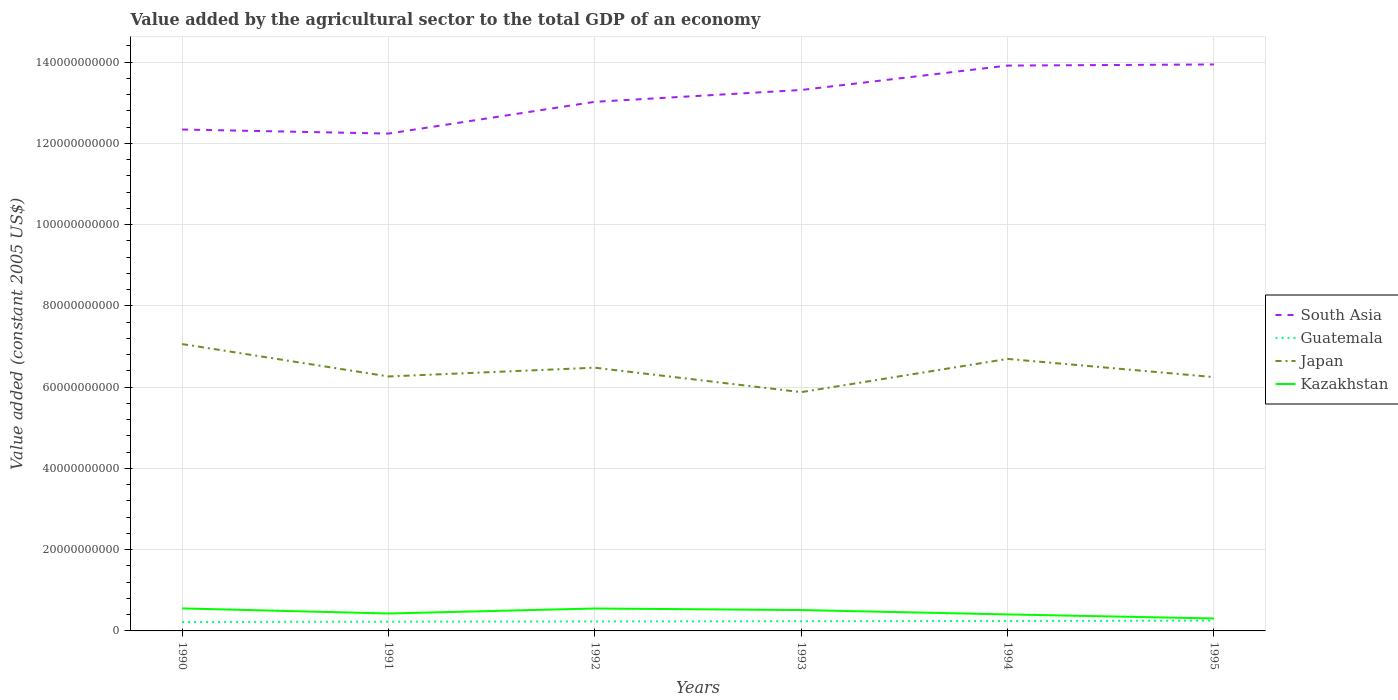Does the line corresponding to South Asia intersect with the line corresponding to Guatemala?
Provide a short and direct response. No. Across all years, what is the maximum value added by the agricultural sector in Japan?
Your answer should be very brief. 5.88e+1. In which year was the value added by the agricultural sector in South Asia maximum?
Provide a succinct answer. 1991. What is the total value added by the agricultural sector in South Asia in the graph?
Keep it short and to the point. -6.01e+09. What is the difference between the highest and the second highest value added by the agricultural sector in Guatemala?
Offer a terse response. 3.31e+08. What is the difference between the highest and the lowest value added by the agricultural sector in Kazakhstan?
Provide a short and direct response. 3. How many years are there in the graph?
Keep it short and to the point. 6. What is the difference between two consecutive major ticks on the Y-axis?
Your answer should be very brief. 2.00e+1. Does the graph contain any zero values?
Ensure brevity in your answer.  No. Where does the legend appear in the graph?
Make the answer very short. Center right. How many legend labels are there?
Keep it short and to the point. 4. What is the title of the graph?
Offer a terse response. Value added by the agricultural sector to the total GDP of an economy. What is the label or title of the Y-axis?
Ensure brevity in your answer.  Value added (constant 2005 US$). What is the Value added (constant 2005 US$) in South Asia in 1990?
Offer a very short reply. 1.23e+11. What is the Value added (constant 2005 US$) in Guatemala in 1990?
Give a very brief answer. 2.20e+09. What is the Value added (constant 2005 US$) in Japan in 1990?
Keep it short and to the point. 7.06e+1. What is the Value added (constant 2005 US$) in Kazakhstan in 1990?
Your response must be concise. 5.54e+09. What is the Value added (constant 2005 US$) in South Asia in 1991?
Your answer should be very brief. 1.22e+11. What is the Value added (constant 2005 US$) of Guatemala in 1991?
Provide a short and direct response. 2.27e+09. What is the Value added (constant 2005 US$) of Japan in 1991?
Your response must be concise. 6.26e+1. What is the Value added (constant 2005 US$) in Kazakhstan in 1991?
Give a very brief answer. 4.29e+09. What is the Value added (constant 2005 US$) of South Asia in 1992?
Give a very brief answer. 1.30e+11. What is the Value added (constant 2005 US$) in Guatemala in 1992?
Make the answer very short. 2.33e+09. What is the Value added (constant 2005 US$) in Japan in 1992?
Provide a succinct answer. 6.48e+1. What is the Value added (constant 2005 US$) in Kazakhstan in 1992?
Offer a terse response. 5.52e+09. What is the Value added (constant 2005 US$) in South Asia in 1993?
Ensure brevity in your answer.  1.33e+11. What is the Value added (constant 2005 US$) in Guatemala in 1993?
Keep it short and to the point. 2.39e+09. What is the Value added (constant 2005 US$) in Japan in 1993?
Your answer should be compact. 5.88e+1. What is the Value added (constant 2005 US$) of Kazakhstan in 1993?
Keep it short and to the point. 5.14e+09. What is the Value added (constant 2005 US$) in South Asia in 1994?
Ensure brevity in your answer.  1.39e+11. What is the Value added (constant 2005 US$) of Guatemala in 1994?
Give a very brief answer. 2.44e+09. What is the Value added (constant 2005 US$) in Japan in 1994?
Keep it short and to the point. 6.69e+1. What is the Value added (constant 2005 US$) of Kazakhstan in 1994?
Offer a terse response. 4.06e+09. What is the Value added (constant 2005 US$) in South Asia in 1995?
Your answer should be compact. 1.39e+11. What is the Value added (constant 2005 US$) of Guatemala in 1995?
Keep it short and to the point. 2.53e+09. What is the Value added (constant 2005 US$) in Japan in 1995?
Provide a short and direct response. 6.25e+1. What is the Value added (constant 2005 US$) in Kazakhstan in 1995?
Your answer should be very brief. 3.07e+09. Across all years, what is the maximum Value added (constant 2005 US$) in South Asia?
Your answer should be compact. 1.39e+11. Across all years, what is the maximum Value added (constant 2005 US$) of Guatemala?
Offer a terse response. 2.53e+09. Across all years, what is the maximum Value added (constant 2005 US$) in Japan?
Provide a succinct answer. 7.06e+1. Across all years, what is the maximum Value added (constant 2005 US$) of Kazakhstan?
Make the answer very short. 5.54e+09. Across all years, what is the minimum Value added (constant 2005 US$) in South Asia?
Your answer should be very brief. 1.22e+11. Across all years, what is the minimum Value added (constant 2005 US$) in Guatemala?
Provide a succinct answer. 2.20e+09. Across all years, what is the minimum Value added (constant 2005 US$) in Japan?
Your response must be concise. 5.88e+1. Across all years, what is the minimum Value added (constant 2005 US$) of Kazakhstan?
Offer a terse response. 3.07e+09. What is the total Value added (constant 2005 US$) in South Asia in the graph?
Your response must be concise. 7.88e+11. What is the total Value added (constant 2005 US$) in Guatemala in the graph?
Your answer should be compact. 1.42e+1. What is the total Value added (constant 2005 US$) of Japan in the graph?
Offer a terse response. 3.86e+11. What is the total Value added (constant 2005 US$) in Kazakhstan in the graph?
Provide a short and direct response. 2.76e+1. What is the difference between the Value added (constant 2005 US$) in South Asia in 1990 and that in 1991?
Your response must be concise. 9.99e+08. What is the difference between the Value added (constant 2005 US$) in Guatemala in 1990 and that in 1991?
Ensure brevity in your answer.  -6.82e+07. What is the difference between the Value added (constant 2005 US$) of Japan in 1990 and that in 1991?
Your answer should be very brief. 7.98e+09. What is the difference between the Value added (constant 2005 US$) in Kazakhstan in 1990 and that in 1991?
Ensure brevity in your answer.  1.25e+09. What is the difference between the Value added (constant 2005 US$) of South Asia in 1990 and that in 1992?
Your answer should be compact. -6.81e+09. What is the difference between the Value added (constant 2005 US$) of Guatemala in 1990 and that in 1992?
Offer a terse response. -1.36e+08. What is the difference between the Value added (constant 2005 US$) in Japan in 1990 and that in 1992?
Provide a succinct answer. 5.82e+09. What is the difference between the Value added (constant 2005 US$) in Kazakhstan in 1990 and that in 1992?
Offer a very short reply. 2.14e+07. What is the difference between the Value added (constant 2005 US$) in South Asia in 1990 and that in 1993?
Keep it short and to the point. -9.73e+09. What is the difference between the Value added (constant 2005 US$) in Guatemala in 1990 and that in 1993?
Provide a short and direct response. -1.87e+08. What is the difference between the Value added (constant 2005 US$) in Japan in 1990 and that in 1993?
Keep it short and to the point. 1.18e+1. What is the difference between the Value added (constant 2005 US$) of Kazakhstan in 1990 and that in 1993?
Offer a terse response. 4.02e+08. What is the difference between the Value added (constant 2005 US$) in South Asia in 1990 and that in 1994?
Your response must be concise. -1.57e+1. What is the difference between the Value added (constant 2005 US$) of Guatemala in 1990 and that in 1994?
Offer a very short reply. -2.46e+08. What is the difference between the Value added (constant 2005 US$) in Japan in 1990 and that in 1994?
Keep it short and to the point. 3.66e+09. What is the difference between the Value added (constant 2005 US$) in Kazakhstan in 1990 and that in 1994?
Provide a succinct answer. 1.48e+09. What is the difference between the Value added (constant 2005 US$) in South Asia in 1990 and that in 1995?
Your answer should be very brief. -1.60e+1. What is the difference between the Value added (constant 2005 US$) in Guatemala in 1990 and that in 1995?
Keep it short and to the point. -3.31e+08. What is the difference between the Value added (constant 2005 US$) in Japan in 1990 and that in 1995?
Your response must be concise. 8.13e+09. What is the difference between the Value added (constant 2005 US$) in Kazakhstan in 1990 and that in 1995?
Offer a terse response. 2.47e+09. What is the difference between the Value added (constant 2005 US$) of South Asia in 1991 and that in 1992?
Offer a very short reply. -7.81e+09. What is the difference between the Value added (constant 2005 US$) in Guatemala in 1991 and that in 1992?
Your answer should be compact. -6.77e+07. What is the difference between the Value added (constant 2005 US$) of Japan in 1991 and that in 1992?
Your answer should be very brief. -2.16e+09. What is the difference between the Value added (constant 2005 US$) in Kazakhstan in 1991 and that in 1992?
Your answer should be very brief. -1.23e+09. What is the difference between the Value added (constant 2005 US$) of South Asia in 1991 and that in 1993?
Your answer should be very brief. -1.07e+1. What is the difference between the Value added (constant 2005 US$) of Guatemala in 1991 and that in 1993?
Ensure brevity in your answer.  -1.19e+08. What is the difference between the Value added (constant 2005 US$) in Japan in 1991 and that in 1993?
Your answer should be very brief. 3.86e+09. What is the difference between the Value added (constant 2005 US$) of Kazakhstan in 1991 and that in 1993?
Your answer should be very brief. -8.50e+08. What is the difference between the Value added (constant 2005 US$) of South Asia in 1991 and that in 1994?
Provide a succinct answer. -1.67e+1. What is the difference between the Value added (constant 2005 US$) in Guatemala in 1991 and that in 1994?
Your answer should be compact. -1.78e+08. What is the difference between the Value added (constant 2005 US$) in Japan in 1991 and that in 1994?
Your answer should be very brief. -4.32e+09. What is the difference between the Value added (constant 2005 US$) of Kazakhstan in 1991 and that in 1994?
Ensure brevity in your answer.  2.29e+08. What is the difference between the Value added (constant 2005 US$) in South Asia in 1991 and that in 1995?
Your answer should be very brief. -1.70e+1. What is the difference between the Value added (constant 2005 US$) of Guatemala in 1991 and that in 1995?
Your response must be concise. -2.63e+08. What is the difference between the Value added (constant 2005 US$) of Japan in 1991 and that in 1995?
Your response must be concise. 1.56e+08. What is the difference between the Value added (constant 2005 US$) in Kazakhstan in 1991 and that in 1995?
Give a very brief answer. 1.22e+09. What is the difference between the Value added (constant 2005 US$) in South Asia in 1992 and that in 1993?
Offer a terse response. -2.91e+09. What is the difference between the Value added (constant 2005 US$) of Guatemala in 1992 and that in 1993?
Offer a terse response. -5.15e+07. What is the difference between the Value added (constant 2005 US$) of Japan in 1992 and that in 1993?
Your answer should be very brief. 6.01e+09. What is the difference between the Value added (constant 2005 US$) in Kazakhstan in 1992 and that in 1993?
Give a very brief answer. 3.81e+08. What is the difference between the Value added (constant 2005 US$) in South Asia in 1992 and that in 1994?
Provide a succinct answer. -8.92e+09. What is the difference between the Value added (constant 2005 US$) of Guatemala in 1992 and that in 1994?
Provide a short and direct response. -1.10e+08. What is the difference between the Value added (constant 2005 US$) of Japan in 1992 and that in 1994?
Your answer should be very brief. -2.16e+09. What is the difference between the Value added (constant 2005 US$) of Kazakhstan in 1992 and that in 1994?
Keep it short and to the point. 1.46e+09. What is the difference between the Value added (constant 2005 US$) of South Asia in 1992 and that in 1995?
Your response must be concise. -9.20e+09. What is the difference between the Value added (constant 2005 US$) in Guatemala in 1992 and that in 1995?
Your answer should be very brief. -1.96e+08. What is the difference between the Value added (constant 2005 US$) of Japan in 1992 and that in 1995?
Give a very brief answer. 2.31e+09. What is the difference between the Value added (constant 2005 US$) in Kazakhstan in 1992 and that in 1995?
Your response must be concise. 2.45e+09. What is the difference between the Value added (constant 2005 US$) in South Asia in 1993 and that in 1994?
Offer a very short reply. -6.01e+09. What is the difference between the Value added (constant 2005 US$) of Guatemala in 1993 and that in 1994?
Make the answer very short. -5.84e+07. What is the difference between the Value added (constant 2005 US$) in Japan in 1993 and that in 1994?
Offer a very short reply. -8.18e+09. What is the difference between the Value added (constant 2005 US$) of Kazakhstan in 1993 and that in 1994?
Offer a terse response. 1.08e+09. What is the difference between the Value added (constant 2005 US$) of South Asia in 1993 and that in 1995?
Keep it short and to the point. -6.28e+09. What is the difference between the Value added (constant 2005 US$) of Guatemala in 1993 and that in 1995?
Ensure brevity in your answer.  -1.44e+08. What is the difference between the Value added (constant 2005 US$) of Japan in 1993 and that in 1995?
Offer a very short reply. -3.70e+09. What is the difference between the Value added (constant 2005 US$) in Kazakhstan in 1993 and that in 1995?
Make the answer very short. 2.07e+09. What is the difference between the Value added (constant 2005 US$) in South Asia in 1994 and that in 1995?
Your response must be concise. -2.77e+08. What is the difference between the Value added (constant 2005 US$) in Guatemala in 1994 and that in 1995?
Make the answer very short. -8.57e+07. What is the difference between the Value added (constant 2005 US$) in Japan in 1994 and that in 1995?
Provide a short and direct response. 4.48e+09. What is the difference between the Value added (constant 2005 US$) of Kazakhstan in 1994 and that in 1995?
Keep it short and to the point. 9.90e+08. What is the difference between the Value added (constant 2005 US$) in South Asia in 1990 and the Value added (constant 2005 US$) in Guatemala in 1991?
Provide a short and direct response. 1.21e+11. What is the difference between the Value added (constant 2005 US$) of South Asia in 1990 and the Value added (constant 2005 US$) of Japan in 1991?
Offer a very short reply. 6.08e+1. What is the difference between the Value added (constant 2005 US$) of South Asia in 1990 and the Value added (constant 2005 US$) of Kazakhstan in 1991?
Your answer should be very brief. 1.19e+11. What is the difference between the Value added (constant 2005 US$) in Guatemala in 1990 and the Value added (constant 2005 US$) in Japan in 1991?
Provide a short and direct response. -6.04e+1. What is the difference between the Value added (constant 2005 US$) of Guatemala in 1990 and the Value added (constant 2005 US$) of Kazakhstan in 1991?
Offer a terse response. -2.09e+09. What is the difference between the Value added (constant 2005 US$) of Japan in 1990 and the Value added (constant 2005 US$) of Kazakhstan in 1991?
Your answer should be very brief. 6.63e+1. What is the difference between the Value added (constant 2005 US$) in South Asia in 1990 and the Value added (constant 2005 US$) in Guatemala in 1992?
Offer a terse response. 1.21e+11. What is the difference between the Value added (constant 2005 US$) in South Asia in 1990 and the Value added (constant 2005 US$) in Japan in 1992?
Your answer should be compact. 5.86e+1. What is the difference between the Value added (constant 2005 US$) in South Asia in 1990 and the Value added (constant 2005 US$) in Kazakhstan in 1992?
Keep it short and to the point. 1.18e+11. What is the difference between the Value added (constant 2005 US$) of Guatemala in 1990 and the Value added (constant 2005 US$) of Japan in 1992?
Offer a very short reply. -6.26e+1. What is the difference between the Value added (constant 2005 US$) of Guatemala in 1990 and the Value added (constant 2005 US$) of Kazakhstan in 1992?
Offer a very short reply. -3.32e+09. What is the difference between the Value added (constant 2005 US$) in Japan in 1990 and the Value added (constant 2005 US$) in Kazakhstan in 1992?
Your response must be concise. 6.51e+1. What is the difference between the Value added (constant 2005 US$) of South Asia in 1990 and the Value added (constant 2005 US$) of Guatemala in 1993?
Your answer should be very brief. 1.21e+11. What is the difference between the Value added (constant 2005 US$) of South Asia in 1990 and the Value added (constant 2005 US$) of Japan in 1993?
Give a very brief answer. 6.46e+1. What is the difference between the Value added (constant 2005 US$) in South Asia in 1990 and the Value added (constant 2005 US$) in Kazakhstan in 1993?
Your answer should be very brief. 1.18e+11. What is the difference between the Value added (constant 2005 US$) of Guatemala in 1990 and the Value added (constant 2005 US$) of Japan in 1993?
Ensure brevity in your answer.  -5.66e+1. What is the difference between the Value added (constant 2005 US$) in Guatemala in 1990 and the Value added (constant 2005 US$) in Kazakhstan in 1993?
Offer a very short reply. -2.94e+09. What is the difference between the Value added (constant 2005 US$) of Japan in 1990 and the Value added (constant 2005 US$) of Kazakhstan in 1993?
Your answer should be very brief. 6.55e+1. What is the difference between the Value added (constant 2005 US$) in South Asia in 1990 and the Value added (constant 2005 US$) in Guatemala in 1994?
Ensure brevity in your answer.  1.21e+11. What is the difference between the Value added (constant 2005 US$) of South Asia in 1990 and the Value added (constant 2005 US$) of Japan in 1994?
Your answer should be compact. 5.65e+1. What is the difference between the Value added (constant 2005 US$) of South Asia in 1990 and the Value added (constant 2005 US$) of Kazakhstan in 1994?
Provide a short and direct response. 1.19e+11. What is the difference between the Value added (constant 2005 US$) in Guatemala in 1990 and the Value added (constant 2005 US$) in Japan in 1994?
Your response must be concise. -6.47e+1. What is the difference between the Value added (constant 2005 US$) of Guatemala in 1990 and the Value added (constant 2005 US$) of Kazakhstan in 1994?
Keep it short and to the point. -1.86e+09. What is the difference between the Value added (constant 2005 US$) of Japan in 1990 and the Value added (constant 2005 US$) of Kazakhstan in 1994?
Give a very brief answer. 6.65e+1. What is the difference between the Value added (constant 2005 US$) of South Asia in 1990 and the Value added (constant 2005 US$) of Guatemala in 1995?
Keep it short and to the point. 1.21e+11. What is the difference between the Value added (constant 2005 US$) of South Asia in 1990 and the Value added (constant 2005 US$) of Japan in 1995?
Your answer should be very brief. 6.09e+1. What is the difference between the Value added (constant 2005 US$) in South Asia in 1990 and the Value added (constant 2005 US$) in Kazakhstan in 1995?
Give a very brief answer. 1.20e+11. What is the difference between the Value added (constant 2005 US$) in Guatemala in 1990 and the Value added (constant 2005 US$) in Japan in 1995?
Your answer should be very brief. -6.03e+1. What is the difference between the Value added (constant 2005 US$) of Guatemala in 1990 and the Value added (constant 2005 US$) of Kazakhstan in 1995?
Keep it short and to the point. -8.71e+08. What is the difference between the Value added (constant 2005 US$) of Japan in 1990 and the Value added (constant 2005 US$) of Kazakhstan in 1995?
Make the answer very short. 6.75e+1. What is the difference between the Value added (constant 2005 US$) in South Asia in 1991 and the Value added (constant 2005 US$) in Guatemala in 1992?
Give a very brief answer. 1.20e+11. What is the difference between the Value added (constant 2005 US$) of South Asia in 1991 and the Value added (constant 2005 US$) of Japan in 1992?
Provide a short and direct response. 5.76e+1. What is the difference between the Value added (constant 2005 US$) of South Asia in 1991 and the Value added (constant 2005 US$) of Kazakhstan in 1992?
Your response must be concise. 1.17e+11. What is the difference between the Value added (constant 2005 US$) in Guatemala in 1991 and the Value added (constant 2005 US$) in Japan in 1992?
Offer a very short reply. -6.25e+1. What is the difference between the Value added (constant 2005 US$) of Guatemala in 1991 and the Value added (constant 2005 US$) of Kazakhstan in 1992?
Provide a succinct answer. -3.25e+09. What is the difference between the Value added (constant 2005 US$) of Japan in 1991 and the Value added (constant 2005 US$) of Kazakhstan in 1992?
Your answer should be compact. 5.71e+1. What is the difference between the Value added (constant 2005 US$) in South Asia in 1991 and the Value added (constant 2005 US$) in Guatemala in 1993?
Provide a short and direct response. 1.20e+11. What is the difference between the Value added (constant 2005 US$) in South Asia in 1991 and the Value added (constant 2005 US$) in Japan in 1993?
Give a very brief answer. 6.36e+1. What is the difference between the Value added (constant 2005 US$) of South Asia in 1991 and the Value added (constant 2005 US$) of Kazakhstan in 1993?
Your response must be concise. 1.17e+11. What is the difference between the Value added (constant 2005 US$) in Guatemala in 1991 and the Value added (constant 2005 US$) in Japan in 1993?
Your answer should be very brief. -5.65e+1. What is the difference between the Value added (constant 2005 US$) in Guatemala in 1991 and the Value added (constant 2005 US$) in Kazakhstan in 1993?
Offer a terse response. -2.87e+09. What is the difference between the Value added (constant 2005 US$) of Japan in 1991 and the Value added (constant 2005 US$) of Kazakhstan in 1993?
Give a very brief answer. 5.75e+1. What is the difference between the Value added (constant 2005 US$) of South Asia in 1991 and the Value added (constant 2005 US$) of Guatemala in 1994?
Your answer should be very brief. 1.20e+11. What is the difference between the Value added (constant 2005 US$) in South Asia in 1991 and the Value added (constant 2005 US$) in Japan in 1994?
Provide a short and direct response. 5.55e+1. What is the difference between the Value added (constant 2005 US$) in South Asia in 1991 and the Value added (constant 2005 US$) in Kazakhstan in 1994?
Ensure brevity in your answer.  1.18e+11. What is the difference between the Value added (constant 2005 US$) of Guatemala in 1991 and the Value added (constant 2005 US$) of Japan in 1994?
Offer a very short reply. -6.47e+1. What is the difference between the Value added (constant 2005 US$) in Guatemala in 1991 and the Value added (constant 2005 US$) in Kazakhstan in 1994?
Provide a short and direct response. -1.79e+09. What is the difference between the Value added (constant 2005 US$) in Japan in 1991 and the Value added (constant 2005 US$) in Kazakhstan in 1994?
Ensure brevity in your answer.  5.86e+1. What is the difference between the Value added (constant 2005 US$) in South Asia in 1991 and the Value added (constant 2005 US$) in Guatemala in 1995?
Provide a succinct answer. 1.20e+11. What is the difference between the Value added (constant 2005 US$) of South Asia in 1991 and the Value added (constant 2005 US$) of Japan in 1995?
Offer a very short reply. 5.99e+1. What is the difference between the Value added (constant 2005 US$) of South Asia in 1991 and the Value added (constant 2005 US$) of Kazakhstan in 1995?
Offer a very short reply. 1.19e+11. What is the difference between the Value added (constant 2005 US$) of Guatemala in 1991 and the Value added (constant 2005 US$) of Japan in 1995?
Offer a very short reply. -6.02e+1. What is the difference between the Value added (constant 2005 US$) of Guatemala in 1991 and the Value added (constant 2005 US$) of Kazakhstan in 1995?
Give a very brief answer. -8.02e+08. What is the difference between the Value added (constant 2005 US$) in Japan in 1991 and the Value added (constant 2005 US$) in Kazakhstan in 1995?
Keep it short and to the point. 5.96e+1. What is the difference between the Value added (constant 2005 US$) of South Asia in 1992 and the Value added (constant 2005 US$) of Guatemala in 1993?
Keep it short and to the point. 1.28e+11. What is the difference between the Value added (constant 2005 US$) in South Asia in 1992 and the Value added (constant 2005 US$) in Japan in 1993?
Ensure brevity in your answer.  7.14e+1. What is the difference between the Value added (constant 2005 US$) in South Asia in 1992 and the Value added (constant 2005 US$) in Kazakhstan in 1993?
Your answer should be compact. 1.25e+11. What is the difference between the Value added (constant 2005 US$) of Guatemala in 1992 and the Value added (constant 2005 US$) of Japan in 1993?
Your answer should be compact. -5.64e+1. What is the difference between the Value added (constant 2005 US$) in Guatemala in 1992 and the Value added (constant 2005 US$) in Kazakhstan in 1993?
Your response must be concise. -2.80e+09. What is the difference between the Value added (constant 2005 US$) in Japan in 1992 and the Value added (constant 2005 US$) in Kazakhstan in 1993?
Provide a short and direct response. 5.96e+1. What is the difference between the Value added (constant 2005 US$) of South Asia in 1992 and the Value added (constant 2005 US$) of Guatemala in 1994?
Give a very brief answer. 1.28e+11. What is the difference between the Value added (constant 2005 US$) of South Asia in 1992 and the Value added (constant 2005 US$) of Japan in 1994?
Keep it short and to the point. 6.33e+1. What is the difference between the Value added (constant 2005 US$) in South Asia in 1992 and the Value added (constant 2005 US$) in Kazakhstan in 1994?
Offer a terse response. 1.26e+11. What is the difference between the Value added (constant 2005 US$) of Guatemala in 1992 and the Value added (constant 2005 US$) of Japan in 1994?
Your answer should be very brief. -6.46e+1. What is the difference between the Value added (constant 2005 US$) of Guatemala in 1992 and the Value added (constant 2005 US$) of Kazakhstan in 1994?
Your answer should be very brief. -1.73e+09. What is the difference between the Value added (constant 2005 US$) in Japan in 1992 and the Value added (constant 2005 US$) in Kazakhstan in 1994?
Offer a terse response. 6.07e+1. What is the difference between the Value added (constant 2005 US$) of South Asia in 1992 and the Value added (constant 2005 US$) of Guatemala in 1995?
Your answer should be very brief. 1.28e+11. What is the difference between the Value added (constant 2005 US$) of South Asia in 1992 and the Value added (constant 2005 US$) of Japan in 1995?
Offer a very short reply. 6.77e+1. What is the difference between the Value added (constant 2005 US$) of South Asia in 1992 and the Value added (constant 2005 US$) of Kazakhstan in 1995?
Offer a terse response. 1.27e+11. What is the difference between the Value added (constant 2005 US$) in Guatemala in 1992 and the Value added (constant 2005 US$) in Japan in 1995?
Your answer should be compact. -6.01e+1. What is the difference between the Value added (constant 2005 US$) in Guatemala in 1992 and the Value added (constant 2005 US$) in Kazakhstan in 1995?
Provide a short and direct response. -7.35e+08. What is the difference between the Value added (constant 2005 US$) of Japan in 1992 and the Value added (constant 2005 US$) of Kazakhstan in 1995?
Your answer should be very brief. 6.17e+1. What is the difference between the Value added (constant 2005 US$) of South Asia in 1993 and the Value added (constant 2005 US$) of Guatemala in 1994?
Give a very brief answer. 1.31e+11. What is the difference between the Value added (constant 2005 US$) in South Asia in 1993 and the Value added (constant 2005 US$) in Japan in 1994?
Your response must be concise. 6.62e+1. What is the difference between the Value added (constant 2005 US$) in South Asia in 1993 and the Value added (constant 2005 US$) in Kazakhstan in 1994?
Your response must be concise. 1.29e+11. What is the difference between the Value added (constant 2005 US$) of Guatemala in 1993 and the Value added (constant 2005 US$) of Japan in 1994?
Your response must be concise. -6.46e+1. What is the difference between the Value added (constant 2005 US$) of Guatemala in 1993 and the Value added (constant 2005 US$) of Kazakhstan in 1994?
Your answer should be very brief. -1.67e+09. What is the difference between the Value added (constant 2005 US$) of Japan in 1993 and the Value added (constant 2005 US$) of Kazakhstan in 1994?
Offer a terse response. 5.47e+1. What is the difference between the Value added (constant 2005 US$) in South Asia in 1993 and the Value added (constant 2005 US$) in Guatemala in 1995?
Ensure brevity in your answer.  1.31e+11. What is the difference between the Value added (constant 2005 US$) in South Asia in 1993 and the Value added (constant 2005 US$) in Japan in 1995?
Provide a short and direct response. 7.07e+1. What is the difference between the Value added (constant 2005 US$) of South Asia in 1993 and the Value added (constant 2005 US$) of Kazakhstan in 1995?
Your answer should be very brief. 1.30e+11. What is the difference between the Value added (constant 2005 US$) in Guatemala in 1993 and the Value added (constant 2005 US$) in Japan in 1995?
Provide a succinct answer. -6.01e+1. What is the difference between the Value added (constant 2005 US$) in Guatemala in 1993 and the Value added (constant 2005 US$) in Kazakhstan in 1995?
Offer a very short reply. -6.83e+08. What is the difference between the Value added (constant 2005 US$) of Japan in 1993 and the Value added (constant 2005 US$) of Kazakhstan in 1995?
Keep it short and to the point. 5.57e+1. What is the difference between the Value added (constant 2005 US$) in South Asia in 1994 and the Value added (constant 2005 US$) in Guatemala in 1995?
Provide a short and direct response. 1.37e+11. What is the difference between the Value added (constant 2005 US$) in South Asia in 1994 and the Value added (constant 2005 US$) in Japan in 1995?
Keep it short and to the point. 7.67e+1. What is the difference between the Value added (constant 2005 US$) in South Asia in 1994 and the Value added (constant 2005 US$) in Kazakhstan in 1995?
Your answer should be compact. 1.36e+11. What is the difference between the Value added (constant 2005 US$) of Guatemala in 1994 and the Value added (constant 2005 US$) of Japan in 1995?
Your answer should be very brief. -6.00e+1. What is the difference between the Value added (constant 2005 US$) in Guatemala in 1994 and the Value added (constant 2005 US$) in Kazakhstan in 1995?
Your answer should be very brief. -6.25e+08. What is the difference between the Value added (constant 2005 US$) in Japan in 1994 and the Value added (constant 2005 US$) in Kazakhstan in 1995?
Ensure brevity in your answer.  6.39e+1. What is the average Value added (constant 2005 US$) of South Asia per year?
Offer a terse response. 1.31e+11. What is the average Value added (constant 2005 US$) of Guatemala per year?
Provide a succinct answer. 2.36e+09. What is the average Value added (constant 2005 US$) of Japan per year?
Provide a short and direct response. 6.44e+1. What is the average Value added (constant 2005 US$) of Kazakhstan per year?
Your response must be concise. 4.60e+09. In the year 1990, what is the difference between the Value added (constant 2005 US$) in South Asia and Value added (constant 2005 US$) in Guatemala?
Your response must be concise. 1.21e+11. In the year 1990, what is the difference between the Value added (constant 2005 US$) of South Asia and Value added (constant 2005 US$) of Japan?
Your answer should be compact. 5.28e+1. In the year 1990, what is the difference between the Value added (constant 2005 US$) in South Asia and Value added (constant 2005 US$) in Kazakhstan?
Your answer should be very brief. 1.18e+11. In the year 1990, what is the difference between the Value added (constant 2005 US$) in Guatemala and Value added (constant 2005 US$) in Japan?
Your answer should be very brief. -6.84e+1. In the year 1990, what is the difference between the Value added (constant 2005 US$) in Guatemala and Value added (constant 2005 US$) in Kazakhstan?
Your answer should be compact. -3.34e+09. In the year 1990, what is the difference between the Value added (constant 2005 US$) in Japan and Value added (constant 2005 US$) in Kazakhstan?
Your answer should be compact. 6.51e+1. In the year 1991, what is the difference between the Value added (constant 2005 US$) of South Asia and Value added (constant 2005 US$) of Guatemala?
Offer a terse response. 1.20e+11. In the year 1991, what is the difference between the Value added (constant 2005 US$) in South Asia and Value added (constant 2005 US$) in Japan?
Offer a very short reply. 5.98e+1. In the year 1991, what is the difference between the Value added (constant 2005 US$) in South Asia and Value added (constant 2005 US$) in Kazakhstan?
Your response must be concise. 1.18e+11. In the year 1991, what is the difference between the Value added (constant 2005 US$) of Guatemala and Value added (constant 2005 US$) of Japan?
Your response must be concise. -6.04e+1. In the year 1991, what is the difference between the Value added (constant 2005 US$) of Guatemala and Value added (constant 2005 US$) of Kazakhstan?
Keep it short and to the point. -2.02e+09. In the year 1991, what is the difference between the Value added (constant 2005 US$) of Japan and Value added (constant 2005 US$) of Kazakhstan?
Your answer should be very brief. 5.83e+1. In the year 1992, what is the difference between the Value added (constant 2005 US$) of South Asia and Value added (constant 2005 US$) of Guatemala?
Offer a very short reply. 1.28e+11. In the year 1992, what is the difference between the Value added (constant 2005 US$) in South Asia and Value added (constant 2005 US$) in Japan?
Provide a succinct answer. 6.54e+1. In the year 1992, what is the difference between the Value added (constant 2005 US$) of South Asia and Value added (constant 2005 US$) of Kazakhstan?
Your answer should be very brief. 1.25e+11. In the year 1992, what is the difference between the Value added (constant 2005 US$) in Guatemala and Value added (constant 2005 US$) in Japan?
Provide a short and direct response. -6.24e+1. In the year 1992, what is the difference between the Value added (constant 2005 US$) in Guatemala and Value added (constant 2005 US$) in Kazakhstan?
Your response must be concise. -3.19e+09. In the year 1992, what is the difference between the Value added (constant 2005 US$) of Japan and Value added (constant 2005 US$) of Kazakhstan?
Provide a short and direct response. 5.93e+1. In the year 1993, what is the difference between the Value added (constant 2005 US$) of South Asia and Value added (constant 2005 US$) of Guatemala?
Give a very brief answer. 1.31e+11. In the year 1993, what is the difference between the Value added (constant 2005 US$) of South Asia and Value added (constant 2005 US$) of Japan?
Ensure brevity in your answer.  7.44e+1. In the year 1993, what is the difference between the Value added (constant 2005 US$) in South Asia and Value added (constant 2005 US$) in Kazakhstan?
Offer a terse response. 1.28e+11. In the year 1993, what is the difference between the Value added (constant 2005 US$) in Guatemala and Value added (constant 2005 US$) in Japan?
Offer a terse response. -5.64e+1. In the year 1993, what is the difference between the Value added (constant 2005 US$) in Guatemala and Value added (constant 2005 US$) in Kazakhstan?
Ensure brevity in your answer.  -2.75e+09. In the year 1993, what is the difference between the Value added (constant 2005 US$) in Japan and Value added (constant 2005 US$) in Kazakhstan?
Provide a short and direct response. 5.36e+1. In the year 1994, what is the difference between the Value added (constant 2005 US$) of South Asia and Value added (constant 2005 US$) of Guatemala?
Your response must be concise. 1.37e+11. In the year 1994, what is the difference between the Value added (constant 2005 US$) in South Asia and Value added (constant 2005 US$) in Japan?
Provide a succinct answer. 7.22e+1. In the year 1994, what is the difference between the Value added (constant 2005 US$) of South Asia and Value added (constant 2005 US$) of Kazakhstan?
Your response must be concise. 1.35e+11. In the year 1994, what is the difference between the Value added (constant 2005 US$) in Guatemala and Value added (constant 2005 US$) in Japan?
Your response must be concise. -6.45e+1. In the year 1994, what is the difference between the Value added (constant 2005 US$) of Guatemala and Value added (constant 2005 US$) of Kazakhstan?
Your answer should be very brief. -1.62e+09. In the year 1994, what is the difference between the Value added (constant 2005 US$) of Japan and Value added (constant 2005 US$) of Kazakhstan?
Offer a terse response. 6.29e+1. In the year 1995, what is the difference between the Value added (constant 2005 US$) of South Asia and Value added (constant 2005 US$) of Guatemala?
Provide a short and direct response. 1.37e+11. In the year 1995, what is the difference between the Value added (constant 2005 US$) of South Asia and Value added (constant 2005 US$) of Japan?
Provide a succinct answer. 7.69e+1. In the year 1995, what is the difference between the Value added (constant 2005 US$) in South Asia and Value added (constant 2005 US$) in Kazakhstan?
Offer a terse response. 1.36e+11. In the year 1995, what is the difference between the Value added (constant 2005 US$) of Guatemala and Value added (constant 2005 US$) of Japan?
Offer a very short reply. -5.99e+1. In the year 1995, what is the difference between the Value added (constant 2005 US$) of Guatemala and Value added (constant 2005 US$) of Kazakhstan?
Your answer should be very brief. -5.39e+08. In the year 1995, what is the difference between the Value added (constant 2005 US$) of Japan and Value added (constant 2005 US$) of Kazakhstan?
Your response must be concise. 5.94e+1. What is the ratio of the Value added (constant 2005 US$) in South Asia in 1990 to that in 1991?
Your response must be concise. 1.01. What is the ratio of the Value added (constant 2005 US$) in Guatemala in 1990 to that in 1991?
Ensure brevity in your answer.  0.97. What is the ratio of the Value added (constant 2005 US$) of Japan in 1990 to that in 1991?
Provide a succinct answer. 1.13. What is the ratio of the Value added (constant 2005 US$) in Kazakhstan in 1990 to that in 1991?
Give a very brief answer. 1.29. What is the ratio of the Value added (constant 2005 US$) of South Asia in 1990 to that in 1992?
Provide a succinct answer. 0.95. What is the ratio of the Value added (constant 2005 US$) in Guatemala in 1990 to that in 1992?
Ensure brevity in your answer.  0.94. What is the ratio of the Value added (constant 2005 US$) of Japan in 1990 to that in 1992?
Ensure brevity in your answer.  1.09. What is the ratio of the Value added (constant 2005 US$) of South Asia in 1990 to that in 1993?
Your answer should be compact. 0.93. What is the ratio of the Value added (constant 2005 US$) of Guatemala in 1990 to that in 1993?
Keep it short and to the point. 0.92. What is the ratio of the Value added (constant 2005 US$) of Japan in 1990 to that in 1993?
Give a very brief answer. 1.2. What is the ratio of the Value added (constant 2005 US$) in Kazakhstan in 1990 to that in 1993?
Your response must be concise. 1.08. What is the ratio of the Value added (constant 2005 US$) of South Asia in 1990 to that in 1994?
Provide a succinct answer. 0.89. What is the ratio of the Value added (constant 2005 US$) in Guatemala in 1990 to that in 1994?
Give a very brief answer. 0.9. What is the ratio of the Value added (constant 2005 US$) of Japan in 1990 to that in 1994?
Give a very brief answer. 1.05. What is the ratio of the Value added (constant 2005 US$) of Kazakhstan in 1990 to that in 1994?
Your answer should be very brief. 1.36. What is the ratio of the Value added (constant 2005 US$) of South Asia in 1990 to that in 1995?
Give a very brief answer. 0.89. What is the ratio of the Value added (constant 2005 US$) in Guatemala in 1990 to that in 1995?
Your answer should be very brief. 0.87. What is the ratio of the Value added (constant 2005 US$) in Japan in 1990 to that in 1995?
Your response must be concise. 1.13. What is the ratio of the Value added (constant 2005 US$) in Kazakhstan in 1990 to that in 1995?
Ensure brevity in your answer.  1.81. What is the ratio of the Value added (constant 2005 US$) of South Asia in 1991 to that in 1992?
Provide a succinct answer. 0.94. What is the ratio of the Value added (constant 2005 US$) of Guatemala in 1991 to that in 1992?
Give a very brief answer. 0.97. What is the ratio of the Value added (constant 2005 US$) in Japan in 1991 to that in 1992?
Offer a terse response. 0.97. What is the ratio of the Value added (constant 2005 US$) in Kazakhstan in 1991 to that in 1992?
Offer a very short reply. 0.78. What is the ratio of the Value added (constant 2005 US$) of South Asia in 1991 to that in 1993?
Your response must be concise. 0.92. What is the ratio of the Value added (constant 2005 US$) of Guatemala in 1991 to that in 1993?
Offer a terse response. 0.95. What is the ratio of the Value added (constant 2005 US$) of Japan in 1991 to that in 1993?
Keep it short and to the point. 1.07. What is the ratio of the Value added (constant 2005 US$) in Kazakhstan in 1991 to that in 1993?
Keep it short and to the point. 0.83. What is the ratio of the Value added (constant 2005 US$) of South Asia in 1991 to that in 1994?
Your response must be concise. 0.88. What is the ratio of the Value added (constant 2005 US$) of Guatemala in 1991 to that in 1994?
Offer a very short reply. 0.93. What is the ratio of the Value added (constant 2005 US$) of Japan in 1991 to that in 1994?
Your answer should be compact. 0.94. What is the ratio of the Value added (constant 2005 US$) of Kazakhstan in 1991 to that in 1994?
Offer a terse response. 1.06. What is the ratio of the Value added (constant 2005 US$) of South Asia in 1991 to that in 1995?
Ensure brevity in your answer.  0.88. What is the ratio of the Value added (constant 2005 US$) in Guatemala in 1991 to that in 1995?
Ensure brevity in your answer.  0.9. What is the ratio of the Value added (constant 2005 US$) in Japan in 1991 to that in 1995?
Ensure brevity in your answer.  1. What is the ratio of the Value added (constant 2005 US$) in Kazakhstan in 1991 to that in 1995?
Your answer should be compact. 1.4. What is the ratio of the Value added (constant 2005 US$) in South Asia in 1992 to that in 1993?
Give a very brief answer. 0.98. What is the ratio of the Value added (constant 2005 US$) of Guatemala in 1992 to that in 1993?
Make the answer very short. 0.98. What is the ratio of the Value added (constant 2005 US$) in Japan in 1992 to that in 1993?
Give a very brief answer. 1.1. What is the ratio of the Value added (constant 2005 US$) in Kazakhstan in 1992 to that in 1993?
Keep it short and to the point. 1.07. What is the ratio of the Value added (constant 2005 US$) in South Asia in 1992 to that in 1994?
Offer a very short reply. 0.94. What is the ratio of the Value added (constant 2005 US$) in Guatemala in 1992 to that in 1994?
Provide a succinct answer. 0.95. What is the ratio of the Value added (constant 2005 US$) in Japan in 1992 to that in 1994?
Offer a very short reply. 0.97. What is the ratio of the Value added (constant 2005 US$) of Kazakhstan in 1992 to that in 1994?
Keep it short and to the point. 1.36. What is the ratio of the Value added (constant 2005 US$) in South Asia in 1992 to that in 1995?
Keep it short and to the point. 0.93. What is the ratio of the Value added (constant 2005 US$) in Guatemala in 1992 to that in 1995?
Give a very brief answer. 0.92. What is the ratio of the Value added (constant 2005 US$) in Kazakhstan in 1992 to that in 1995?
Give a very brief answer. 1.8. What is the ratio of the Value added (constant 2005 US$) of South Asia in 1993 to that in 1994?
Offer a very short reply. 0.96. What is the ratio of the Value added (constant 2005 US$) of Guatemala in 1993 to that in 1994?
Provide a succinct answer. 0.98. What is the ratio of the Value added (constant 2005 US$) in Japan in 1993 to that in 1994?
Keep it short and to the point. 0.88. What is the ratio of the Value added (constant 2005 US$) in Kazakhstan in 1993 to that in 1994?
Provide a succinct answer. 1.27. What is the ratio of the Value added (constant 2005 US$) in South Asia in 1993 to that in 1995?
Keep it short and to the point. 0.95. What is the ratio of the Value added (constant 2005 US$) in Guatemala in 1993 to that in 1995?
Your answer should be compact. 0.94. What is the ratio of the Value added (constant 2005 US$) of Japan in 1993 to that in 1995?
Your answer should be compact. 0.94. What is the ratio of the Value added (constant 2005 US$) in Kazakhstan in 1993 to that in 1995?
Your answer should be compact. 1.67. What is the ratio of the Value added (constant 2005 US$) of South Asia in 1994 to that in 1995?
Make the answer very short. 1. What is the ratio of the Value added (constant 2005 US$) of Guatemala in 1994 to that in 1995?
Your answer should be very brief. 0.97. What is the ratio of the Value added (constant 2005 US$) in Japan in 1994 to that in 1995?
Offer a very short reply. 1.07. What is the ratio of the Value added (constant 2005 US$) of Kazakhstan in 1994 to that in 1995?
Your answer should be very brief. 1.32. What is the difference between the highest and the second highest Value added (constant 2005 US$) in South Asia?
Provide a succinct answer. 2.77e+08. What is the difference between the highest and the second highest Value added (constant 2005 US$) of Guatemala?
Give a very brief answer. 8.57e+07. What is the difference between the highest and the second highest Value added (constant 2005 US$) in Japan?
Keep it short and to the point. 3.66e+09. What is the difference between the highest and the second highest Value added (constant 2005 US$) of Kazakhstan?
Your answer should be very brief. 2.14e+07. What is the difference between the highest and the lowest Value added (constant 2005 US$) of South Asia?
Your answer should be compact. 1.70e+1. What is the difference between the highest and the lowest Value added (constant 2005 US$) in Guatemala?
Give a very brief answer. 3.31e+08. What is the difference between the highest and the lowest Value added (constant 2005 US$) in Japan?
Keep it short and to the point. 1.18e+1. What is the difference between the highest and the lowest Value added (constant 2005 US$) in Kazakhstan?
Provide a short and direct response. 2.47e+09. 